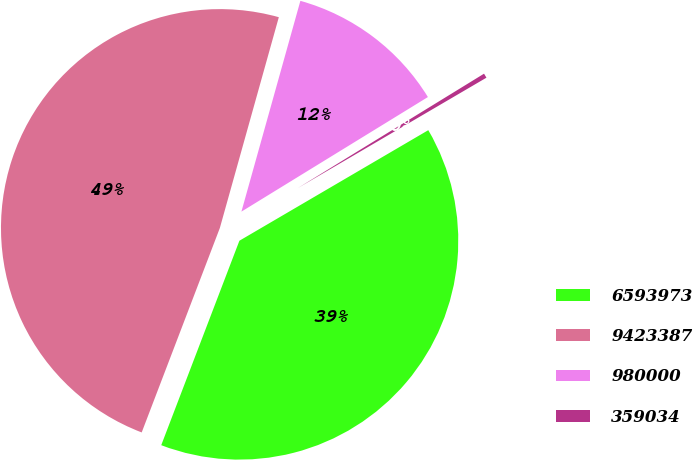Convert chart to OTSL. <chart><loc_0><loc_0><loc_500><loc_500><pie_chart><fcel>6593973<fcel>9423387<fcel>980000<fcel>359034<nl><fcel>39.24%<fcel>48.53%<fcel>11.89%<fcel>0.34%<nl></chart> 